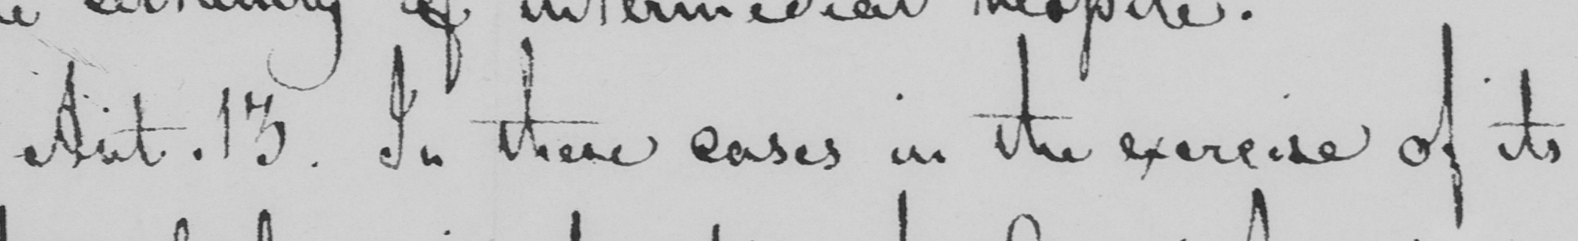Transcribe the text shown in this historical manuscript line. Art . 13 . In these cases in the exercise of its 